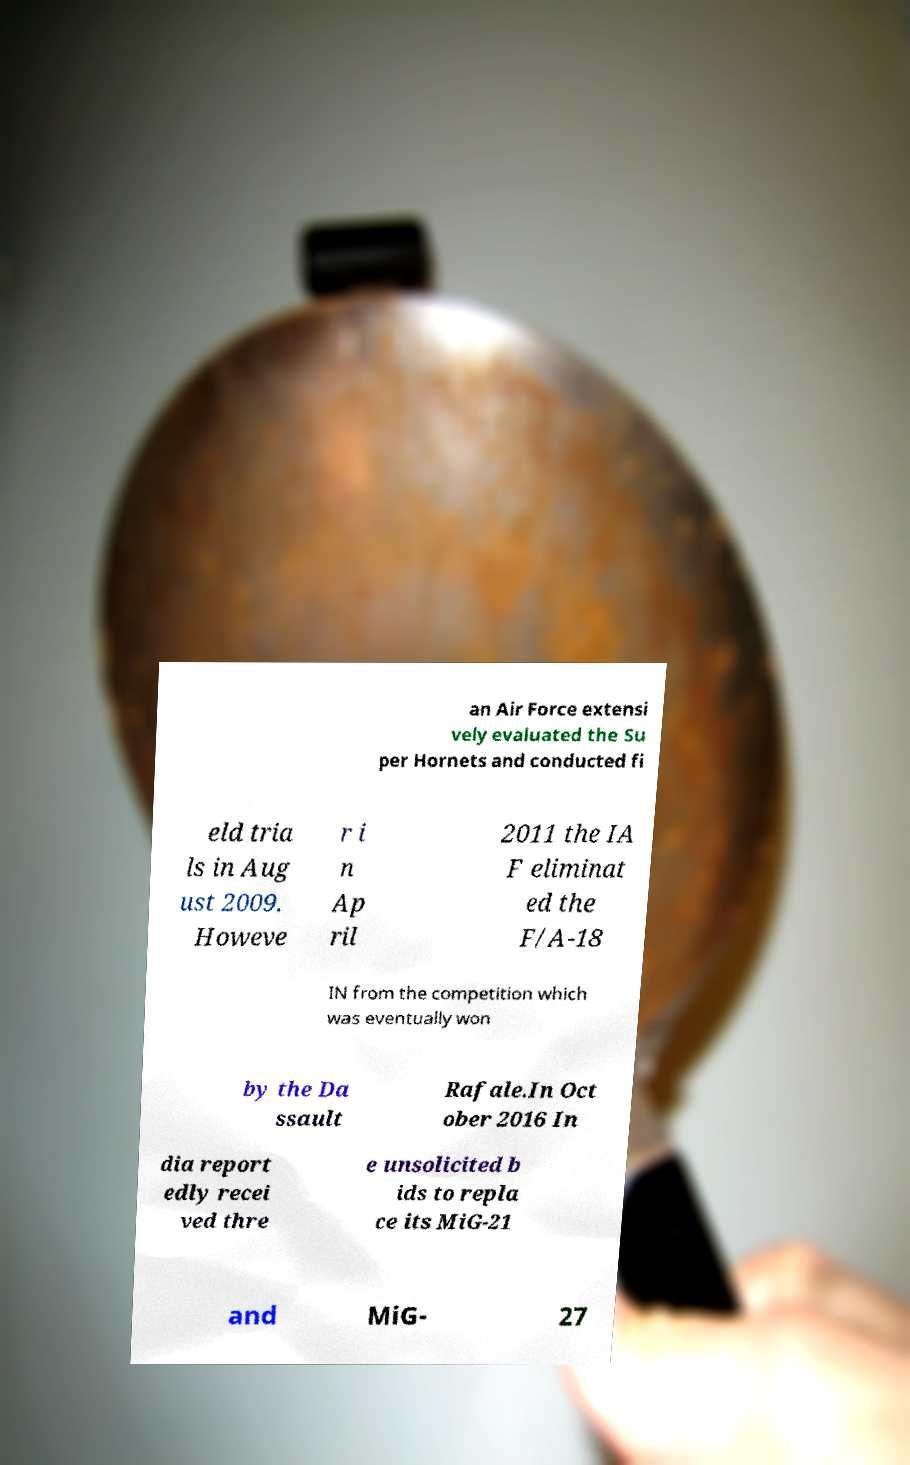Can you accurately transcribe the text from the provided image for me? an Air Force extensi vely evaluated the Su per Hornets and conducted fi eld tria ls in Aug ust 2009. Howeve r i n Ap ril 2011 the IA F eliminat ed the F/A-18 IN from the competition which was eventually won by the Da ssault Rafale.In Oct ober 2016 In dia report edly recei ved thre e unsolicited b ids to repla ce its MiG-21 and MiG- 27 